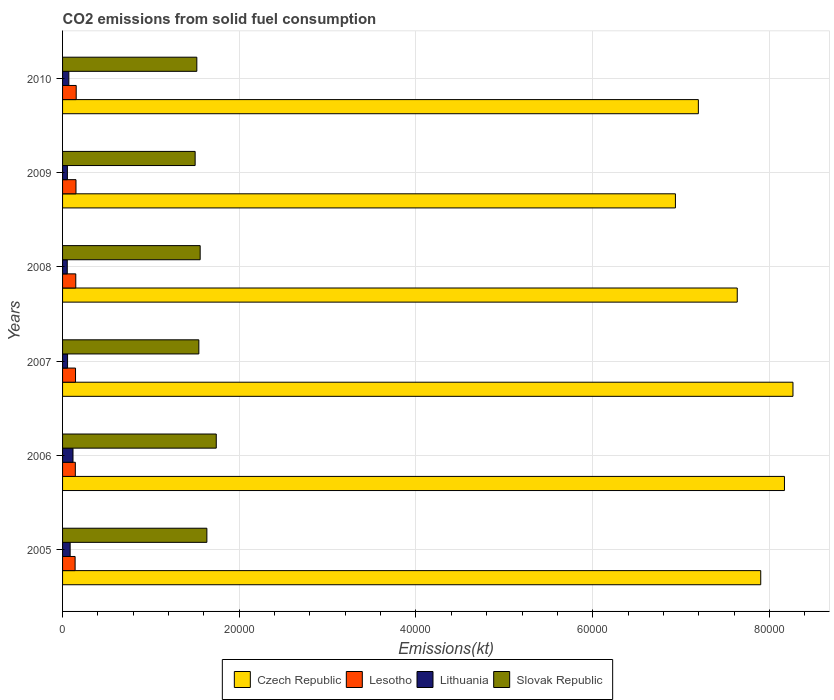How many groups of bars are there?
Keep it short and to the point. 6. Are the number of bars per tick equal to the number of legend labels?
Offer a very short reply. Yes. How many bars are there on the 3rd tick from the top?
Your answer should be very brief. 4. In how many cases, is the number of bars for a given year not equal to the number of legend labels?
Offer a terse response. 0. What is the amount of CO2 emitted in Czech Republic in 2008?
Provide a succinct answer. 7.64e+04. Across all years, what is the maximum amount of CO2 emitted in Czech Republic?
Ensure brevity in your answer.  8.27e+04. Across all years, what is the minimum amount of CO2 emitted in Lesotho?
Ensure brevity in your answer.  1419.13. In which year was the amount of CO2 emitted in Czech Republic minimum?
Provide a succinct answer. 2009. What is the total amount of CO2 emitted in Slovak Republic in the graph?
Your answer should be very brief. 9.49e+04. What is the difference between the amount of CO2 emitted in Lithuania in 2007 and that in 2010?
Make the answer very short. -146.68. What is the difference between the amount of CO2 emitted in Lesotho in 2005 and the amount of CO2 emitted in Slovak Republic in 2009?
Your answer should be compact. -1.36e+04. What is the average amount of CO2 emitted in Lesotho per year?
Keep it short and to the point. 1481.47. In the year 2008, what is the difference between the amount of CO2 emitted in Lithuania and amount of CO2 emitted in Czech Republic?
Provide a succinct answer. -7.58e+04. What is the ratio of the amount of CO2 emitted in Lithuania in 2006 to that in 2008?
Keep it short and to the point. 2.22. Is the difference between the amount of CO2 emitted in Lithuania in 2006 and 2008 greater than the difference between the amount of CO2 emitted in Czech Republic in 2006 and 2008?
Your answer should be very brief. No. What is the difference between the highest and the second highest amount of CO2 emitted in Lesotho?
Your answer should be compact. 25.67. What is the difference between the highest and the lowest amount of CO2 emitted in Lithuania?
Make the answer very short. 649.06. Is the sum of the amount of CO2 emitted in Czech Republic in 2008 and 2010 greater than the maximum amount of CO2 emitted in Lesotho across all years?
Your response must be concise. Yes. What does the 2nd bar from the top in 2007 represents?
Offer a terse response. Lithuania. What does the 4th bar from the bottom in 2006 represents?
Keep it short and to the point. Slovak Republic. How many bars are there?
Make the answer very short. 24. Are the values on the major ticks of X-axis written in scientific E-notation?
Your answer should be compact. No. What is the title of the graph?
Your response must be concise. CO2 emissions from solid fuel consumption. What is the label or title of the X-axis?
Your answer should be very brief. Emissions(kt). What is the Emissions(kt) of Czech Republic in 2005?
Provide a short and direct response. 7.90e+04. What is the Emissions(kt) of Lesotho in 2005?
Offer a terse response. 1419.13. What is the Emissions(kt) of Lithuania in 2005?
Your answer should be very brief. 858.08. What is the Emissions(kt) of Slovak Republic in 2005?
Offer a terse response. 1.63e+04. What is the Emissions(kt) of Czech Republic in 2006?
Provide a short and direct response. 8.17e+04. What is the Emissions(kt) of Lesotho in 2006?
Offer a very short reply. 1444.8. What is the Emissions(kt) of Lithuania in 2006?
Make the answer very short. 1180.77. What is the Emissions(kt) in Slovak Republic in 2006?
Offer a very short reply. 1.74e+04. What is the Emissions(kt) in Czech Republic in 2007?
Your answer should be compact. 8.27e+04. What is the Emissions(kt) in Lesotho in 2007?
Make the answer very short. 1466.8. What is the Emissions(kt) of Lithuania in 2007?
Your answer should be compact. 564.72. What is the Emissions(kt) in Slovak Republic in 2007?
Provide a short and direct response. 1.54e+04. What is the Emissions(kt) in Czech Republic in 2008?
Your answer should be compact. 7.64e+04. What is the Emissions(kt) of Lesotho in 2008?
Provide a short and direct response. 1496.14. What is the Emissions(kt) in Lithuania in 2008?
Keep it short and to the point. 531.72. What is the Emissions(kt) of Slovak Republic in 2008?
Your response must be concise. 1.56e+04. What is the Emissions(kt) in Czech Republic in 2009?
Offer a terse response. 6.94e+04. What is the Emissions(kt) of Lesotho in 2009?
Your answer should be very brief. 1518.14. What is the Emissions(kt) in Lithuania in 2009?
Offer a very short reply. 546.38. What is the Emissions(kt) in Slovak Republic in 2009?
Your answer should be compact. 1.50e+04. What is the Emissions(kt) in Czech Republic in 2010?
Provide a succinct answer. 7.20e+04. What is the Emissions(kt) in Lesotho in 2010?
Offer a terse response. 1543.81. What is the Emissions(kt) of Lithuania in 2010?
Offer a very short reply. 711.4. What is the Emissions(kt) in Slovak Republic in 2010?
Your response must be concise. 1.52e+04. Across all years, what is the maximum Emissions(kt) of Czech Republic?
Offer a very short reply. 8.27e+04. Across all years, what is the maximum Emissions(kt) of Lesotho?
Provide a short and direct response. 1543.81. Across all years, what is the maximum Emissions(kt) of Lithuania?
Provide a succinct answer. 1180.77. Across all years, what is the maximum Emissions(kt) in Slovak Republic?
Your answer should be compact. 1.74e+04. Across all years, what is the minimum Emissions(kt) in Czech Republic?
Offer a terse response. 6.94e+04. Across all years, what is the minimum Emissions(kt) of Lesotho?
Your answer should be compact. 1419.13. Across all years, what is the minimum Emissions(kt) in Lithuania?
Offer a terse response. 531.72. Across all years, what is the minimum Emissions(kt) of Slovak Republic?
Your answer should be compact. 1.50e+04. What is the total Emissions(kt) of Czech Republic in the graph?
Provide a succinct answer. 4.61e+05. What is the total Emissions(kt) of Lesotho in the graph?
Your answer should be compact. 8888.81. What is the total Emissions(kt) in Lithuania in the graph?
Provide a short and direct response. 4393.07. What is the total Emissions(kt) in Slovak Republic in the graph?
Make the answer very short. 9.49e+04. What is the difference between the Emissions(kt) of Czech Republic in 2005 and that in 2006?
Keep it short and to the point. -2684.24. What is the difference between the Emissions(kt) of Lesotho in 2005 and that in 2006?
Offer a terse response. -25.67. What is the difference between the Emissions(kt) in Lithuania in 2005 and that in 2006?
Give a very brief answer. -322.7. What is the difference between the Emissions(kt) in Slovak Republic in 2005 and that in 2006?
Ensure brevity in your answer.  -1063.43. What is the difference between the Emissions(kt) in Czech Republic in 2005 and that in 2007?
Provide a short and direct response. -3648.66. What is the difference between the Emissions(kt) of Lesotho in 2005 and that in 2007?
Your response must be concise. -47.67. What is the difference between the Emissions(kt) in Lithuania in 2005 and that in 2007?
Your answer should be compact. 293.36. What is the difference between the Emissions(kt) of Slovak Republic in 2005 and that in 2007?
Your response must be concise. 909.42. What is the difference between the Emissions(kt) in Czech Republic in 2005 and that in 2008?
Your answer should be very brief. 2658.57. What is the difference between the Emissions(kt) in Lesotho in 2005 and that in 2008?
Your response must be concise. -77.01. What is the difference between the Emissions(kt) of Lithuania in 2005 and that in 2008?
Your response must be concise. 326.36. What is the difference between the Emissions(kt) in Slovak Republic in 2005 and that in 2008?
Provide a succinct answer. 759.07. What is the difference between the Emissions(kt) of Czech Republic in 2005 and that in 2009?
Keep it short and to the point. 9655.21. What is the difference between the Emissions(kt) in Lesotho in 2005 and that in 2009?
Make the answer very short. -99.01. What is the difference between the Emissions(kt) of Lithuania in 2005 and that in 2009?
Ensure brevity in your answer.  311.69. What is the difference between the Emissions(kt) in Slovak Republic in 2005 and that in 2009?
Provide a succinct answer. 1327.45. What is the difference between the Emissions(kt) of Czech Republic in 2005 and that in 2010?
Provide a short and direct response. 7058.98. What is the difference between the Emissions(kt) in Lesotho in 2005 and that in 2010?
Keep it short and to the point. -124.68. What is the difference between the Emissions(kt) in Lithuania in 2005 and that in 2010?
Provide a succinct answer. 146.68. What is the difference between the Emissions(kt) of Slovak Republic in 2005 and that in 2010?
Provide a succinct answer. 1136.77. What is the difference between the Emissions(kt) in Czech Republic in 2006 and that in 2007?
Your answer should be very brief. -964.42. What is the difference between the Emissions(kt) of Lesotho in 2006 and that in 2007?
Your answer should be very brief. -22. What is the difference between the Emissions(kt) of Lithuania in 2006 and that in 2007?
Provide a short and direct response. 616.06. What is the difference between the Emissions(kt) in Slovak Republic in 2006 and that in 2007?
Offer a very short reply. 1972.85. What is the difference between the Emissions(kt) of Czech Republic in 2006 and that in 2008?
Provide a short and direct response. 5342.82. What is the difference between the Emissions(kt) in Lesotho in 2006 and that in 2008?
Provide a short and direct response. -51.34. What is the difference between the Emissions(kt) in Lithuania in 2006 and that in 2008?
Your answer should be compact. 649.06. What is the difference between the Emissions(kt) in Slovak Republic in 2006 and that in 2008?
Make the answer very short. 1822.5. What is the difference between the Emissions(kt) in Czech Republic in 2006 and that in 2009?
Your answer should be compact. 1.23e+04. What is the difference between the Emissions(kt) in Lesotho in 2006 and that in 2009?
Give a very brief answer. -73.34. What is the difference between the Emissions(kt) in Lithuania in 2006 and that in 2009?
Your answer should be compact. 634.39. What is the difference between the Emissions(kt) of Slovak Republic in 2006 and that in 2009?
Give a very brief answer. 2390.88. What is the difference between the Emissions(kt) in Czech Republic in 2006 and that in 2010?
Ensure brevity in your answer.  9743.22. What is the difference between the Emissions(kt) in Lesotho in 2006 and that in 2010?
Ensure brevity in your answer.  -99.01. What is the difference between the Emissions(kt) in Lithuania in 2006 and that in 2010?
Your response must be concise. 469.38. What is the difference between the Emissions(kt) in Slovak Republic in 2006 and that in 2010?
Your response must be concise. 2200.2. What is the difference between the Emissions(kt) in Czech Republic in 2007 and that in 2008?
Give a very brief answer. 6307.24. What is the difference between the Emissions(kt) in Lesotho in 2007 and that in 2008?
Make the answer very short. -29.34. What is the difference between the Emissions(kt) of Lithuania in 2007 and that in 2008?
Give a very brief answer. 33. What is the difference between the Emissions(kt) of Slovak Republic in 2007 and that in 2008?
Offer a terse response. -150.35. What is the difference between the Emissions(kt) of Czech Republic in 2007 and that in 2009?
Provide a succinct answer. 1.33e+04. What is the difference between the Emissions(kt) in Lesotho in 2007 and that in 2009?
Offer a very short reply. -51.34. What is the difference between the Emissions(kt) in Lithuania in 2007 and that in 2009?
Your answer should be very brief. 18.34. What is the difference between the Emissions(kt) of Slovak Republic in 2007 and that in 2009?
Your answer should be compact. 418.04. What is the difference between the Emissions(kt) of Czech Republic in 2007 and that in 2010?
Your answer should be very brief. 1.07e+04. What is the difference between the Emissions(kt) in Lesotho in 2007 and that in 2010?
Your answer should be very brief. -77.01. What is the difference between the Emissions(kt) in Lithuania in 2007 and that in 2010?
Ensure brevity in your answer.  -146.68. What is the difference between the Emissions(kt) of Slovak Republic in 2007 and that in 2010?
Make the answer very short. 227.35. What is the difference between the Emissions(kt) of Czech Republic in 2008 and that in 2009?
Your answer should be very brief. 6996.64. What is the difference between the Emissions(kt) of Lesotho in 2008 and that in 2009?
Your response must be concise. -22. What is the difference between the Emissions(kt) in Lithuania in 2008 and that in 2009?
Your answer should be compact. -14.67. What is the difference between the Emissions(kt) of Slovak Republic in 2008 and that in 2009?
Offer a terse response. 568.38. What is the difference between the Emissions(kt) of Czech Republic in 2008 and that in 2010?
Provide a succinct answer. 4400.4. What is the difference between the Emissions(kt) of Lesotho in 2008 and that in 2010?
Your answer should be very brief. -47.67. What is the difference between the Emissions(kt) of Lithuania in 2008 and that in 2010?
Your answer should be compact. -179.68. What is the difference between the Emissions(kt) of Slovak Republic in 2008 and that in 2010?
Provide a short and direct response. 377.7. What is the difference between the Emissions(kt) in Czech Republic in 2009 and that in 2010?
Provide a succinct answer. -2596.24. What is the difference between the Emissions(kt) of Lesotho in 2009 and that in 2010?
Make the answer very short. -25.67. What is the difference between the Emissions(kt) in Lithuania in 2009 and that in 2010?
Your response must be concise. -165.01. What is the difference between the Emissions(kt) of Slovak Republic in 2009 and that in 2010?
Offer a very short reply. -190.68. What is the difference between the Emissions(kt) of Czech Republic in 2005 and the Emissions(kt) of Lesotho in 2006?
Make the answer very short. 7.76e+04. What is the difference between the Emissions(kt) in Czech Republic in 2005 and the Emissions(kt) in Lithuania in 2006?
Your answer should be compact. 7.78e+04. What is the difference between the Emissions(kt) of Czech Republic in 2005 and the Emissions(kt) of Slovak Republic in 2006?
Give a very brief answer. 6.16e+04. What is the difference between the Emissions(kt) of Lesotho in 2005 and the Emissions(kt) of Lithuania in 2006?
Provide a succinct answer. 238.35. What is the difference between the Emissions(kt) in Lesotho in 2005 and the Emissions(kt) in Slovak Republic in 2006?
Ensure brevity in your answer.  -1.60e+04. What is the difference between the Emissions(kt) of Lithuania in 2005 and the Emissions(kt) of Slovak Republic in 2006?
Keep it short and to the point. -1.65e+04. What is the difference between the Emissions(kt) of Czech Republic in 2005 and the Emissions(kt) of Lesotho in 2007?
Your answer should be very brief. 7.76e+04. What is the difference between the Emissions(kt) in Czech Republic in 2005 and the Emissions(kt) in Lithuania in 2007?
Your response must be concise. 7.85e+04. What is the difference between the Emissions(kt) in Czech Republic in 2005 and the Emissions(kt) in Slovak Republic in 2007?
Make the answer very short. 6.36e+04. What is the difference between the Emissions(kt) in Lesotho in 2005 and the Emissions(kt) in Lithuania in 2007?
Make the answer very short. 854.41. What is the difference between the Emissions(kt) of Lesotho in 2005 and the Emissions(kt) of Slovak Republic in 2007?
Provide a short and direct response. -1.40e+04. What is the difference between the Emissions(kt) of Lithuania in 2005 and the Emissions(kt) of Slovak Republic in 2007?
Your answer should be compact. -1.46e+04. What is the difference between the Emissions(kt) in Czech Republic in 2005 and the Emissions(kt) in Lesotho in 2008?
Ensure brevity in your answer.  7.75e+04. What is the difference between the Emissions(kt) in Czech Republic in 2005 and the Emissions(kt) in Lithuania in 2008?
Make the answer very short. 7.85e+04. What is the difference between the Emissions(kt) in Czech Republic in 2005 and the Emissions(kt) in Slovak Republic in 2008?
Offer a very short reply. 6.34e+04. What is the difference between the Emissions(kt) of Lesotho in 2005 and the Emissions(kt) of Lithuania in 2008?
Your response must be concise. 887.41. What is the difference between the Emissions(kt) of Lesotho in 2005 and the Emissions(kt) of Slovak Republic in 2008?
Your response must be concise. -1.42e+04. What is the difference between the Emissions(kt) in Lithuania in 2005 and the Emissions(kt) in Slovak Republic in 2008?
Your answer should be very brief. -1.47e+04. What is the difference between the Emissions(kt) in Czech Republic in 2005 and the Emissions(kt) in Lesotho in 2009?
Keep it short and to the point. 7.75e+04. What is the difference between the Emissions(kt) of Czech Republic in 2005 and the Emissions(kt) of Lithuania in 2009?
Offer a terse response. 7.85e+04. What is the difference between the Emissions(kt) in Czech Republic in 2005 and the Emissions(kt) in Slovak Republic in 2009?
Your answer should be very brief. 6.40e+04. What is the difference between the Emissions(kt) in Lesotho in 2005 and the Emissions(kt) in Lithuania in 2009?
Your response must be concise. 872.75. What is the difference between the Emissions(kt) of Lesotho in 2005 and the Emissions(kt) of Slovak Republic in 2009?
Provide a short and direct response. -1.36e+04. What is the difference between the Emissions(kt) in Lithuania in 2005 and the Emissions(kt) in Slovak Republic in 2009?
Offer a very short reply. -1.41e+04. What is the difference between the Emissions(kt) in Czech Republic in 2005 and the Emissions(kt) in Lesotho in 2010?
Your answer should be very brief. 7.75e+04. What is the difference between the Emissions(kt) of Czech Republic in 2005 and the Emissions(kt) of Lithuania in 2010?
Your answer should be compact. 7.83e+04. What is the difference between the Emissions(kt) of Czech Republic in 2005 and the Emissions(kt) of Slovak Republic in 2010?
Provide a short and direct response. 6.38e+04. What is the difference between the Emissions(kt) of Lesotho in 2005 and the Emissions(kt) of Lithuania in 2010?
Give a very brief answer. 707.73. What is the difference between the Emissions(kt) in Lesotho in 2005 and the Emissions(kt) in Slovak Republic in 2010?
Offer a terse response. -1.38e+04. What is the difference between the Emissions(kt) in Lithuania in 2005 and the Emissions(kt) in Slovak Republic in 2010?
Your response must be concise. -1.43e+04. What is the difference between the Emissions(kt) in Czech Republic in 2006 and the Emissions(kt) in Lesotho in 2007?
Your answer should be very brief. 8.02e+04. What is the difference between the Emissions(kt) of Czech Republic in 2006 and the Emissions(kt) of Lithuania in 2007?
Offer a terse response. 8.11e+04. What is the difference between the Emissions(kt) of Czech Republic in 2006 and the Emissions(kt) of Slovak Republic in 2007?
Your answer should be very brief. 6.63e+04. What is the difference between the Emissions(kt) of Lesotho in 2006 and the Emissions(kt) of Lithuania in 2007?
Provide a short and direct response. 880.08. What is the difference between the Emissions(kt) in Lesotho in 2006 and the Emissions(kt) in Slovak Republic in 2007?
Offer a terse response. -1.40e+04. What is the difference between the Emissions(kt) in Lithuania in 2006 and the Emissions(kt) in Slovak Republic in 2007?
Ensure brevity in your answer.  -1.42e+04. What is the difference between the Emissions(kt) in Czech Republic in 2006 and the Emissions(kt) in Lesotho in 2008?
Give a very brief answer. 8.02e+04. What is the difference between the Emissions(kt) of Czech Republic in 2006 and the Emissions(kt) of Lithuania in 2008?
Offer a very short reply. 8.12e+04. What is the difference between the Emissions(kt) of Czech Republic in 2006 and the Emissions(kt) of Slovak Republic in 2008?
Ensure brevity in your answer.  6.61e+04. What is the difference between the Emissions(kt) in Lesotho in 2006 and the Emissions(kt) in Lithuania in 2008?
Provide a succinct answer. 913.08. What is the difference between the Emissions(kt) in Lesotho in 2006 and the Emissions(kt) in Slovak Republic in 2008?
Give a very brief answer. -1.41e+04. What is the difference between the Emissions(kt) in Lithuania in 2006 and the Emissions(kt) in Slovak Republic in 2008?
Offer a terse response. -1.44e+04. What is the difference between the Emissions(kt) in Czech Republic in 2006 and the Emissions(kt) in Lesotho in 2009?
Make the answer very short. 8.02e+04. What is the difference between the Emissions(kt) of Czech Republic in 2006 and the Emissions(kt) of Lithuania in 2009?
Your answer should be very brief. 8.12e+04. What is the difference between the Emissions(kt) of Czech Republic in 2006 and the Emissions(kt) of Slovak Republic in 2009?
Ensure brevity in your answer.  6.67e+04. What is the difference between the Emissions(kt) of Lesotho in 2006 and the Emissions(kt) of Lithuania in 2009?
Offer a terse response. 898.41. What is the difference between the Emissions(kt) of Lesotho in 2006 and the Emissions(kt) of Slovak Republic in 2009?
Offer a terse response. -1.36e+04. What is the difference between the Emissions(kt) of Lithuania in 2006 and the Emissions(kt) of Slovak Republic in 2009?
Provide a short and direct response. -1.38e+04. What is the difference between the Emissions(kt) of Czech Republic in 2006 and the Emissions(kt) of Lesotho in 2010?
Offer a very short reply. 8.02e+04. What is the difference between the Emissions(kt) of Czech Republic in 2006 and the Emissions(kt) of Lithuania in 2010?
Provide a succinct answer. 8.10e+04. What is the difference between the Emissions(kt) of Czech Republic in 2006 and the Emissions(kt) of Slovak Republic in 2010?
Offer a very short reply. 6.65e+04. What is the difference between the Emissions(kt) of Lesotho in 2006 and the Emissions(kt) of Lithuania in 2010?
Ensure brevity in your answer.  733.4. What is the difference between the Emissions(kt) of Lesotho in 2006 and the Emissions(kt) of Slovak Republic in 2010?
Your answer should be compact. -1.38e+04. What is the difference between the Emissions(kt) of Lithuania in 2006 and the Emissions(kt) of Slovak Republic in 2010?
Give a very brief answer. -1.40e+04. What is the difference between the Emissions(kt) in Czech Republic in 2007 and the Emissions(kt) in Lesotho in 2008?
Provide a succinct answer. 8.12e+04. What is the difference between the Emissions(kt) of Czech Republic in 2007 and the Emissions(kt) of Lithuania in 2008?
Give a very brief answer. 8.21e+04. What is the difference between the Emissions(kt) in Czech Republic in 2007 and the Emissions(kt) in Slovak Republic in 2008?
Give a very brief answer. 6.71e+04. What is the difference between the Emissions(kt) in Lesotho in 2007 and the Emissions(kt) in Lithuania in 2008?
Give a very brief answer. 935.09. What is the difference between the Emissions(kt) of Lesotho in 2007 and the Emissions(kt) of Slovak Republic in 2008?
Offer a very short reply. -1.41e+04. What is the difference between the Emissions(kt) of Lithuania in 2007 and the Emissions(kt) of Slovak Republic in 2008?
Make the answer very short. -1.50e+04. What is the difference between the Emissions(kt) of Czech Republic in 2007 and the Emissions(kt) of Lesotho in 2009?
Ensure brevity in your answer.  8.12e+04. What is the difference between the Emissions(kt) of Czech Republic in 2007 and the Emissions(kt) of Lithuania in 2009?
Make the answer very short. 8.21e+04. What is the difference between the Emissions(kt) in Czech Republic in 2007 and the Emissions(kt) in Slovak Republic in 2009?
Your answer should be very brief. 6.77e+04. What is the difference between the Emissions(kt) in Lesotho in 2007 and the Emissions(kt) in Lithuania in 2009?
Offer a very short reply. 920.42. What is the difference between the Emissions(kt) of Lesotho in 2007 and the Emissions(kt) of Slovak Republic in 2009?
Your answer should be very brief. -1.35e+04. What is the difference between the Emissions(kt) of Lithuania in 2007 and the Emissions(kt) of Slovak Republic in 2009?
Make the answer very short. -1.44e+04. What is the difference between the Emissions(kt) of Czech Republic in 2007 and the Emissions(kt) of Lesotho in 2010?
Make the answer very short. 8.11e+04. What is the difference between the Emissions(kt) in Czech Republic in 2007 and the Emissions(kt) in Lithuania in 2010?
Give a very brief answer. 8.20e+04. What is the difference between the Emissions(kt) of Czech Republic in 2007 and the Emissions(kt) of Slovak Republic in 2010?
Ensure brevity in your answer.  6.75e+04. What is the difference between the Emissions(kt) of Lesotho in 2007 and the Emissions(kt) of Lithuania in 2010?
Provide a succinct answer. 755.4. What is the difference between the Emissions(kt) in Lesotho in 2007 and the Emissions(kt) in Slovak Republic in 2010?
Your answer should be very brief. -1.37e+04. What is the difference between the Emissions(kt) in Lithuania in 2007 and the Emissions(kt) in Slovak Republic in 2010?
Your answer should be compact. -1.46e+04. What is the difference between the Emissions(kt) of Czech Republic in 2008 and the Emissions(kt) of Lesotho in 2009?
Give a very brief answer. 7.48e+04. What is the difference between the Emissions(kt) of Czech Republic in 2008 and the Emissions(kt) of Lithuania in 2009?
Your answer should be very brief. 7.58e+04. What is the difference between the Emissions(kt) of Czech Republic in 2008 and the Emissions(kt) of Slovak Republic in 2009?
Your response must be concise. 6.14e+04. What is the difference between the Emissions(kt) in Lesotho in 2008 and the Emissions(kt) in Lithuania in 2009?
Give a very brief answer. 949.75. What is the difference between the Emissions(kt) in Lesotho in 2008 and the Emissions(kt) in Slovak Republic in 2009?
Ensure brevity in your answer.  -1.35e+04. What is the difference between the Emissions(kt) in Lithuania in 2008 and the Emissions(kt) in Slovak Republic in 2009?
Keep it short and to the point. -1.45e+04. What is the difference between the Emissions(kt) of Czech Republic in 2008 and the Emissions(kt) of Lesotho in 2010?
Offer a terse response. 7.48e+04. What is the difference between the Emissions(kt) of Czech Republic in 2008 and the Emissions(kt) of Lithuania in 2010?
Ensure brevity in your answer.  7.57e+04. What is the difference between the Emissions(kt) of Czech Republic in 2008 and the Emissions(kt) of Slovak Republic in 2010?
Give a very brief answer. 6.12e+04. What is the difference between the Emissions(kt) in Lesotho in 2008 and the Emissions(kt) in Lithuania in 2010?
Provide a succinct answer. 784.74. What is the difference between the Emissions(kt) in Lesotho in 2008 and the Emissions(kt) in Slovak Republic in 2010?
Your answer should be compact. -1.37e+04. What is the difference between the Emissions(kt) in Lithuania in 2008 and the Emissions(kt) in Slovak Republic in 2010?
Keep it short and to the point. -1.47e+04. What is the difference between the Emissions(kt) of Czech Republic in 2009 and the Emissions(kt) of Lesotho in 2010?
Your answer should be very brief. 6.78e+04. What is the difference between the Emissions(kt) in Czech Republic in 2009 and the Emissions(kt) in Lithuania in 2010?
Your answer should be compact. 6.87e+04. What is the difference between the Emissions(kt) in Czech Republic in 2009 and the Emissions(kt) in Slovak Republic in 2010?
Your response must be concise. 5.42e+04. What is the difference between the Emissions(kt) of Lesotho in 2009 and the Emissions(kt) of Lithuania in 2010?
Give a very brief answer. 806.74. What is the difference between the Emissions(kt) of Lesotho in 2009 and the Emissions(kt) of Slovak Republic in 2010?
Ensure brevity in your answer.  -1.37e+04. What is the difference between the Emissions(kt) in Lithuania in 2009 and the Emissions(kt) in Slovak Republic in 2010?
Your answer should be compact. -1.46e+04. What is the average Emissions(kt) of Czech Republic per year?
Make the answer very short. 7.68e+04. What is the average Emissions(kt) in Lesotho per year?
Make the answer very short. 1481.47. What is the average Emissions(kt) of Lithuania per year?
Keep it short and to the point. 732.18. What is the average Emissions(kt) in Slovak Republic per year?
Offer a very short reply. 1.58e+04. In the year 2005, what is the difference between the Emissions(kt) in Czech Republic and Emissions(kt) in Lesotho?
Provide a succinct answer. 7.76e+04. In the year 2005, what is the difference between the Emissions(kt) in Czech Republic and Emissions(kt) in Lithuania?
Ensure brevity in your answer.  7.82e+04. In the year 2005, what is the difference between the Emissions(kt) in Czech Republic and Emissions(kt) in Slovak Republic?
Your response must be concise. 6.27e+04. In the year 2005, what is the difference between the Emissions(kt) of Lesotho and Emissions(kt) of Lithuania?
Your response must be concise. 561.05. In the year 2005, what is the difference between the Emissions(kt) in Lesotho and Emissions(kt) in Slovak Republic?
Make the answer very short. -1.49e+04. In the year 2005, what is the difference between the Emissions(kt) of Lithuania and Emissions(kt) of Slovak Republic?
Offer a very short reply. -1.55e+04. In the year 2006, what is the difference between the Emissions(kt) in Czech Republic and Emissions(kt) in Lesotho?
Make the answer very short. 8.03e+04. In the year 2006, what is the difference between the Emissions(kt) of Czech Republic and Emissions(kt) of Lithuania?
Provide a succinct answer. 8.05e+04. In the year 2006, what is the difference between the Emissions(kt) in Czech Republic and Emissions(kt) in Slovak Republic?
Provide a short and direct response. 6.43e+04. In the year 2006, what is the difference between the Emissions(kt) of Lesotho and Emissions(kt) of Lithuania?
Your answer should be compact. 264.02. In the year 2006, what is the difference between the Emissions(kt) in Lesotho and Emissions(kt) in Slovak Republic?
Offer a very short reply. -1.60e+04. In the year 2006, what is the difference between the Emissions(kt) in Lithuania and Emissions(kt) in Slovak Republic?
Keep it short and to the point. -1.62e+04. In the year 2007, what is the difference between the Emissions(kt) of Czech Republic and Emissions(kt) of Lesotho?
Make the answer very short. 8.12e+04. In the year 2007, what is the difference between the Emissions(kt) in Czech Republic and Emissions(kt) in Lithuania?
Your response must be concise. 8.21e+04. In the year 2007, what is the difference between the Emissions(kt) in Czech Republic and Emissions(kt) in Slovak Republic?
Your answer should be compact. 6.72e+04. In the year 2007, what is the difference between the Emissions(kt) of Lesotho and Emissions(kt) of Lithuania?
Your response must be concise. 902.08. In the year 2007, what is the difference between the Emissions(kt) of Lesotho and Emissions(kt) of Slovak Republic?
Your response must be concise. -1.40e+04. In the year 2007, what is the difference between the Emissions(kt) in Lithuania and Emissions(kt) in Slovak Republic?
Provide a succinct answer. -1.49e+04. In the year 2008, what is the difference between the Emissions(kt) of Czech Republic and Emissions(kt) of Lesotho?
Keep it short and to the point. 7.49e+04. In the year 2008, what is the difference between the Emissions(kt) of Czech Republic and Emissions(kt) of Lithuania?
Ensure brevity in your answer.  7.58e+04. In the year 2008, what is the difference between the Emissions(kt) in Czech Republic and Emissions(kt) in Slovak Republic?
Provide a succinct answer. 6.08e+04. In the year 2008, what is the difference between the Emissions(kt) of Lesotho and Emissions(kt) of Lithuania?
Provide a short and direct response. 964.42. In the year 2008, what is the difference between the Emissions(kt) of Lesotho and Emissions(kt) of Slovak Republic?
Offer a terse response. -1.41e+04. In the year 2008, what is the difference between the Emissions(kt) in Lithuania and Emissions(kt) in Slovak Republic?
Give a very brief answer. -1.50e+04. In the year 2009, what is the difference between the Emissions(kt) in Czech Republic and Emissions(kt) in Lesotho?
Your response must be concise. 6.78e+04. In the year 2009, what is the difference between the Emissions(kt) of Czech Republic and Emissions(kt) of Lithuania?
Your response must be concise. 6.88e+04. In the year 2009, what is the difference between the Emissions(kt) in Czech Republic and Emissions(kt) in Slovak Republic?
Provide a short and direct response. 5.44e+04. In the year 2009, what is the difference between the Emissions(kt) in Lesotho and Emissions(kt) in Lithuania?
Keep it short and to the point. 971.75. In the year 2009, what is the difference between the Emissions(kt) of Lesotho and Emissions(kt) of Slovak Republic?
Provide a succinct answer. -1.35e+04. In the year 2009, what is the difference between the Emissions(kt) in Lithuania and Emissions(kt) in Slovak Republic?
Your answer should be compact. -1.45e+04. In the year 2010, what is the difference between the Emissions(kt) of Czech Republic and Emissions(kt) of Lesotho?
Provide a succinct answer. 7.04e+04. In the year 2010, what is the difference between the Emissions(kt) of Czech Republic and Emissions(kt) of Lithuania?
Keep it short and to the point. 7.12e+04. In the year 2010, what is the difference between the Emissions(kt) in Czech Republic and Emissions(kt) in Slovak Republic?
Your answer should be very brief. 5.68e+04. In the year 2010, what is the difference between the Emissions(kt) in Lesotho and Emissions(kt) in Lithuania?
Give a very brief answer. 832.41. In the year 2010, what is the difference between the Emissions(kt) in Lesotho and Emissions(kt) in Slovak Republic?
Give a very brief answer. -1.37e+04. In the year 2010, what is the difference between the Emissions(kt) of Lithuania and Emissions(kt) of Slovak Republic?
Offer a terse response. -1.45e+04. What is the ratio of the Emissions(kt) of Czech Republic in 2005 to that in 2006?
Your response must be concise. 0.97. What is the ratio of the Emissions(kt) of Lesotho in 2005 to that in 2006?
Make the answer very short. 0.98. What is the ratio of the Emissions(kt) of Lithuania in 2005 to that in 2006?
Offer a terse response. 0.73. What is the ratio of the Emissions(kt) in Slovak Republic in 2005 to that in 2006?
Your response must be concise. 0.94. What is the ratio of the Emissions(kt) of Czech Republic in 2005 to that in 2007?
Your response must be concise. 0.96. What is the ratio of the Emissions(kt) in Lesotho in 2005 to that in 2007?
Make the answer very short. 0.97. What is the ratio of the Emissions(kt) in Lithuania in 2005 to that in 2007?
Keep it short and to the point. 1.52. What is the ratio of the Emissions(kt) in Slovak Republic in 2005 to that in 2007?
Offer a terse response. 1.06. What is the ratio of the Emissions(kt) of Czech Republic in 2005 to that in 2008?
Keep it short and to the point. 1.03. What is the ratio of the Emissions(kt) of Lesotho in 2005 to that in 2008?
Your answer should be compact. 0.95. What is the ratio of the Emissions(kt) of Lithuania in 2005 to that in 2008?
Provide a short and direct response. 1.61. What is the ratio of the Emissions(kt) of Slovak Republic in 2005 to that in 2008?
Make the answer very short. 1.05. What is the ratio of the Emissions(kt) of Czech Republic in 2005 to that in 2009?
Ensure brevity in your answer.  1.14. What is the ratio of the Emissions(kt) of Lesotho in 2005 to that in 2009?
Your answer should be very brief. 0.93. What is the ratio of the Emissions(kt) of Lithuania in 2005 to that in 2009?
Your response must be concise. 1.57. What is the ratio of the Emissions(kt) of Slovak Republic in 2005 to that in 2009?
Your answer should be very brief. 1.09. What is the ratio of the Emissions(kt) of Czech Republic in 2005 to that in 2010?
Provide a succinct answer. 1.1. What is the ratio of the Emissions(kt) in Lesotho in 2005 to that in 2010?
Offer a very short reply. 0.92. What is the ratio of the Emissions(kt) in Lithuania in 2005 to that in 2010?
Provide a short and direct response. 1.21. What is the ratio of the Emissions(kt) in Slovak Republic in 2005 to that in 2010?
Make the answer very short. 1.07. What is the ratio of the Emissions(kt) in Czech Republic in 2006 to that in 2007?
Your response must be concise. 0.99. What is the ratio of the Emissions(kt) of Lesotho in 2006 to that in 2007?
Ensure brevity in your answer.  0.98. What is the ratio of the Emissions(kt) of Lithuania in 2006 to that in 2007?
Your response must be concise. 2.09. What is the ratio of the Emissions(kt) in Slovak Republic in 2006 to that in 2007?
Make the answer very short. 1.13. What is the ratio of the Emissions(kt) in Czech Republic in 2006 to that in 2008?
Provide a succinct answer. 1.07. What is the ratio of the Emissions(kt) of Lesotho in 2006 to that in 2008?
Offer a terse response. 0.97. What is the ratio of the Emissions(kt) in Lithuania in 2006 to that in 2008?
Keep it short and to the point. 2.22. What is the ratio of the Emissions(kt) in Slovak Republic in 2006 to that in 2008?
Your answer should be very brief. 1.12. What is the ratio of the Emissions(kt) of Czech Republic in 2006 to that in 2009?
Offer a terse response. 1.18. What is the ratio of the Emissions(kt) in Lesotho in 2006 to that in 2009?
Provide a short and direct response. 0.95. What is the ratio of the Emissions(kt) in Lithuania in 2006 to that in 2009?
Ensure brevity in your answer.  2.16. What is the ratio of the Emissions(kt) of Slovak Republic in 2006 to that in 2009?
Keep it short and to the point. 1.16. What is the ratio of the Emissions(kt) of Czech Republic in 2006 to that in 2010?
Provide a short and direct response. 1.14. What is the ratio of the Emissions(kt) in Lesotho in 2006 to that in 2010?
Your answer should be compact. 0.94. What is the ratio of the Emissions(kt) of Lithuania in 2006 to that in 2010?
Your answer should be very brief. 1.66. What is the ratio of the Emissions(kt) in Slovak Republic in 2006 to that in 2010?
Offer a very short reply. 1.14. What is the ratio of the Emissions(kt) in Czech Republic in 2007 to that in 2008?
Make the answer very short. 1.08. What is the ratio of the Emissions(kt) of Lesotho in 2007 to that in 2008?
Provide a succinct answer. 0.98. What is the ratio of the Emissions(kt) in Lithuania in 2007 to that in 2008?
Provide a short and direct response. 1.06. What is the ratio of the Emissions(kt) in Slovak Republic in 2007 to that in 2008?
Provide a short and direct response. 0.99. What is the ratio of the Emissions(kt) of Czech Republic in 2007 to that in 2009?
Offer a very short reply. 1.19. What is the ratio of the Emissions(kt) in Lesotho in 2007 to that in 2009?
Offer a very short reply. 0.97. What is the ratio of the Emissions(kt) of Lithuania in 2007 to that in 2009?
Your answer should be very brief. 1.03. What is the ratio of the Emissions(kt) in Slovak Republic in 2007 to that in 2009?
Keep it short and to the point. 1.03. What is the ratio of the Emissions(kt) in Czech Republic in 2007 to that in 2010?
Make the answer very short. 1.15. What is the ratio of the Emissions(kt) in Lesotho in 2007 to that in 2010?
Your answer should be very brief. 0.95. What is the ratio of the Emissions(kt) of Lithuania in 2007 to that in 2010?
Your response must be concise. 0.79. What is the ratio of the Emissions(kt) in Czech Republic in 2008 to that in 2009?
Your answer should be compact. 1.1. What is the ratio of the Emissions(kt) of Lesotho in 2008 to that in 2009?
Offer a terse response. 0.99. What is the ratio of the Emissions(kt) of Lithuania in 2008 to that in 2009?
Your answer should be compact. 0.97. What is the ratio of the Emissions(kt) in Slovak Republic in 2008 to that in 2009?
Your answer should be compact. 1.04. What is the ratio of the Emissions(kt) in Czech Republic in 2008 to that in 2010?
Provide a short and direct response. 1.06. What is the ratio of the Emissions(kt) of Lesotho in 2008 to that in 2010?
Make the answer very short. 0.97. What is the ratio of the Emissions(kt) of Lithuania in 2008 to that in 2010?
Offer a very short reply. 0.75. What is the ratio of the Emissions(kt) of Slovak Republic in 2008 to that in 2010?
Offer a terse response. 1.02. What is the ratio of the Emissions(kt) in Czech Republic in 2009 to that in 2010?
Ensure brevity in your answer.  0.96. What is the ratio of the Emissions(kt) in Lesotho in 2009 to that in 2010?
Ensure brevity in your answer.  0.98. What is the ratio of the Emissions(kt) in Lithuania in 2009 to that in 2010?
Offer a very short reply. 0.77. What is the ratio of the Emissions(kt) in Slovak Republic in 2009 to that in 2010?
Provide a succinct answer. 0.99. What is the difference between the highest and the second highest Emissions(kt) of Czech Republic?
Your answer should be very brief. 964.42. What is the difference between the highest and the second highest Emissions(kt) of Lesotho?
Offer a terse response. 25.67. What is the difference between the highest and the second highest Emissions(kt) of Lithuania?
Provide a short and direct response. 322.7. What is the difference between the highest and the second highest Emissions(kt) of Slovak Republic?
Offer a very short reply. 1063.43. What is the difference between the highest and the lowest Emissions(kt) in Czech Republic?
Give a very brief answer. 1.33e+04. What is the difference between the highest and the lowest Emissions(kt) in Lesotho?
Your answer should be very brief. 124.68. What is the difference between the highest and the lowest Emissions(kt) in Lithuania?
Provide a succinct answer. 649.06. What is the difference between the highest and the lowest Emissions(kt) in Slovak Republic?
Offer a terse response. 2390.88. 